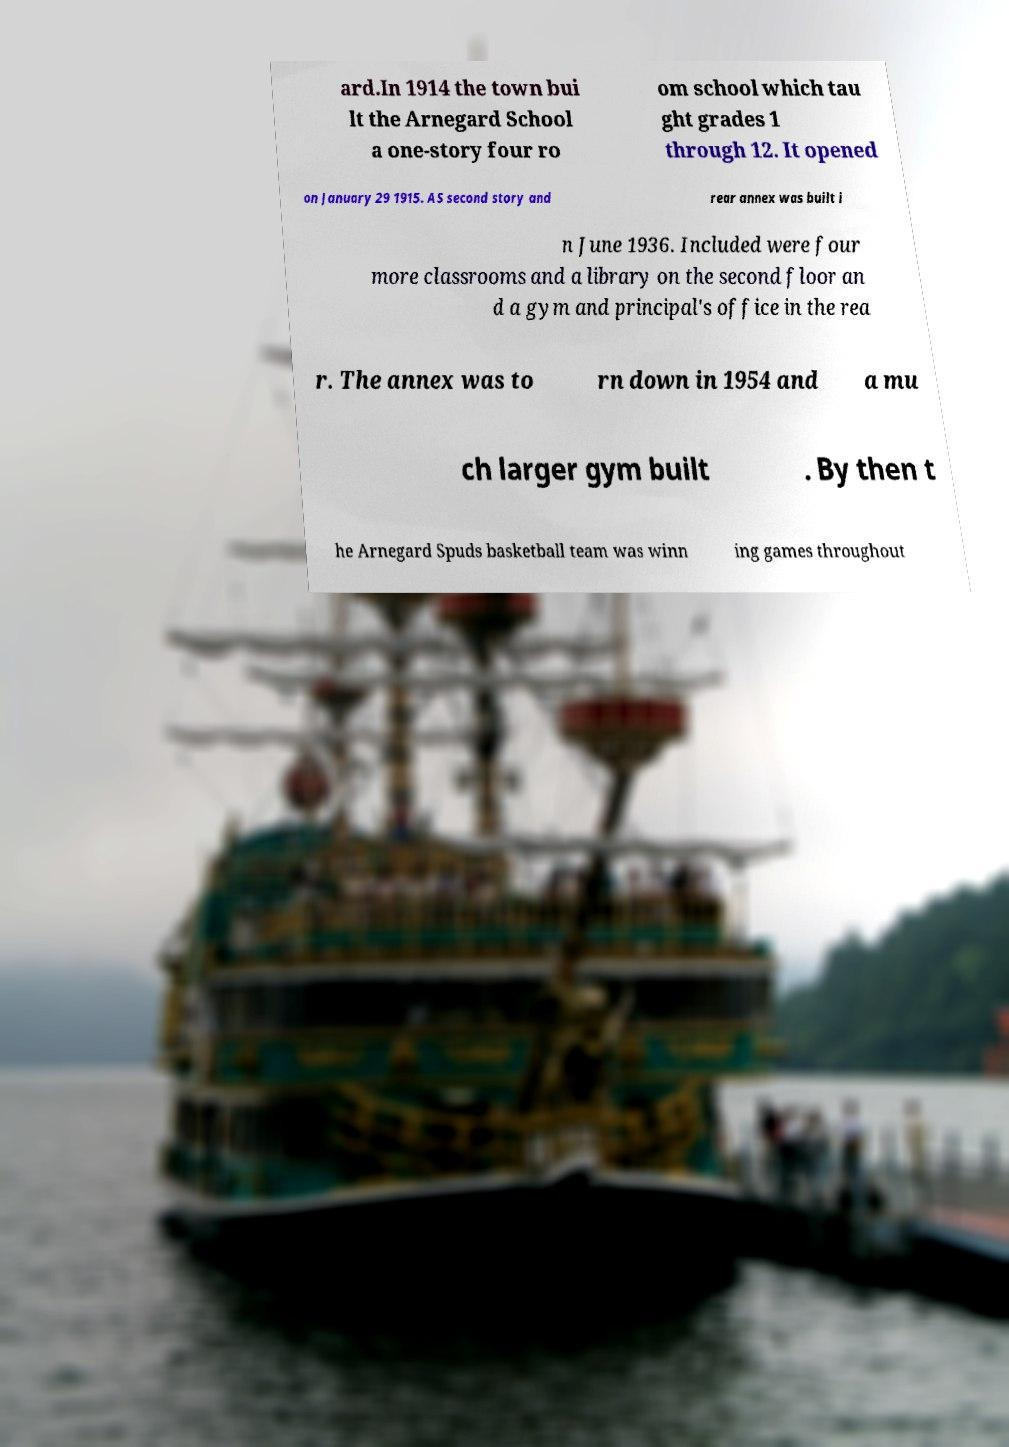I need the written content from this picture converted into text. Can you do that? ard.In 1914 the town bui lt the Arnegard School a one-story four ro om school which tau ght grades 1 through 12. It opened on January 29 1915. AS second story and rear annex was built i n June 1936. Included were four more classrooms and a library on the second floor an d a gym and principal's office in the rea r. The annex was to rn down in 1954 and a mu ch larger gym built . By then t he Arnegard Spuds basketball team was winn ing games throughout 